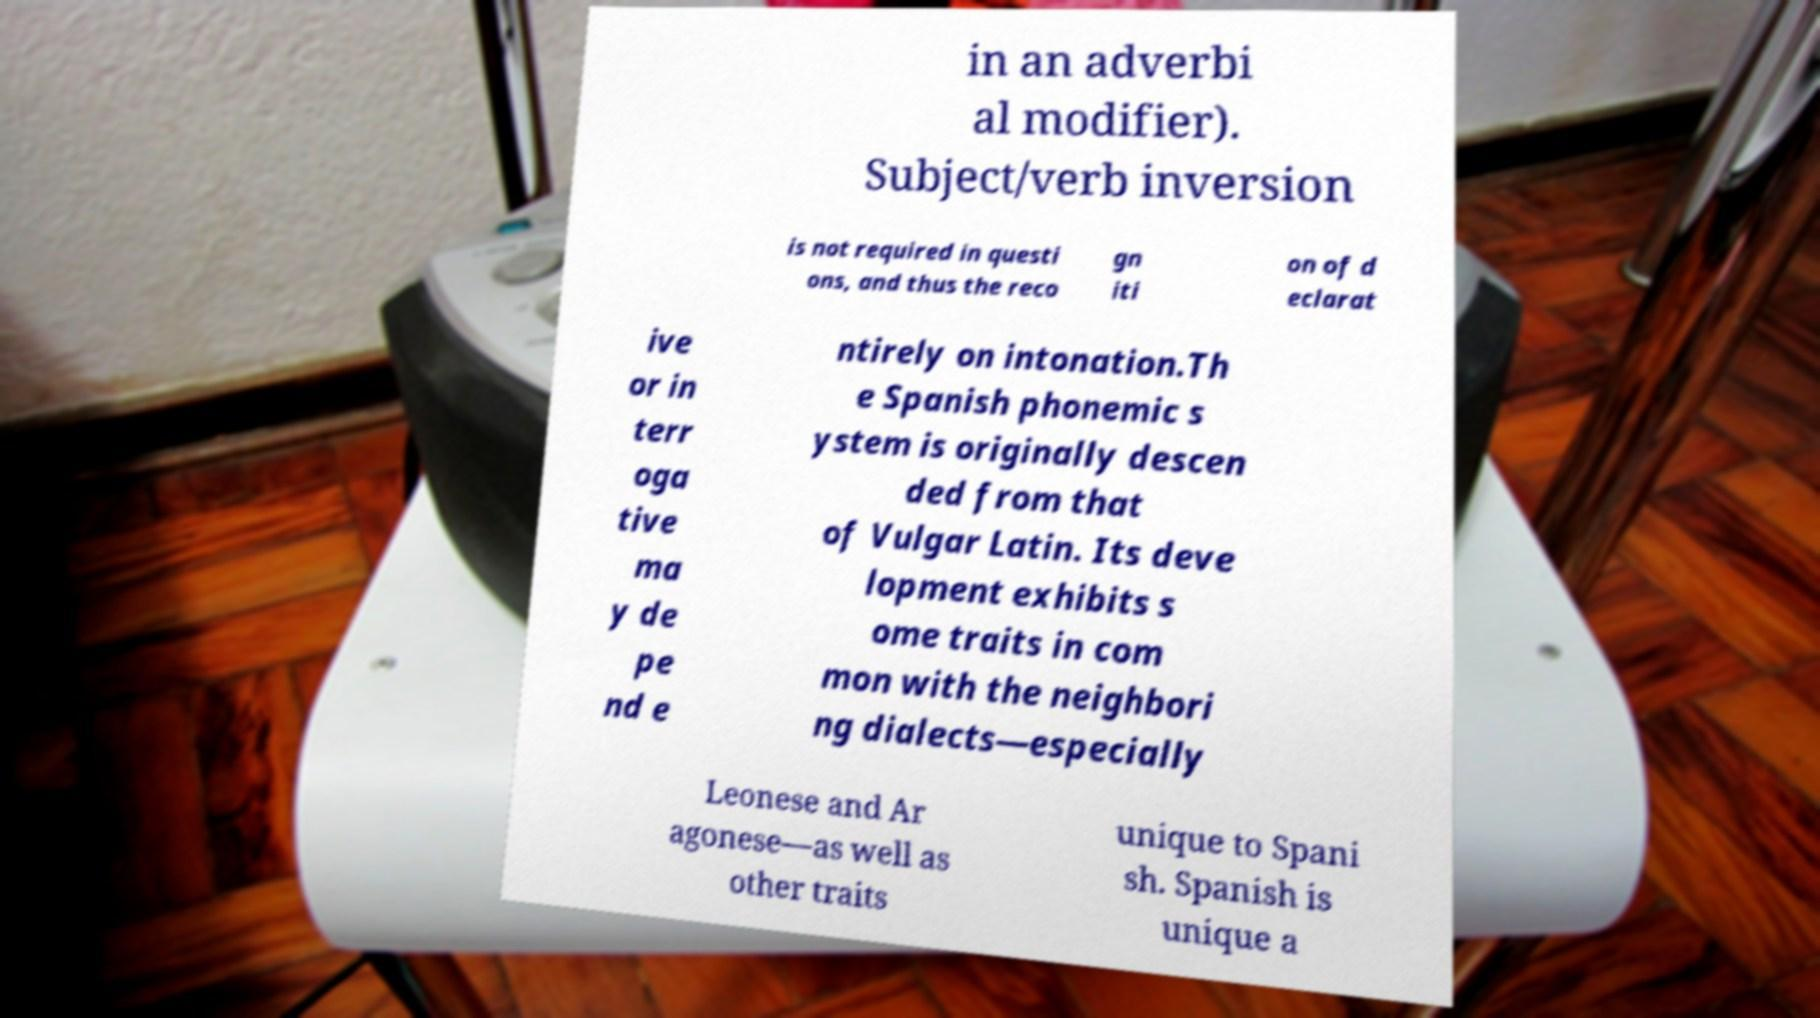What messages or text are displayed in this image? I need them in a readable, typed format. in an adverbi al modifier). Subject/verb inversion is not required in questi ons, and thus the reco gn iti on of d eclarat ive or in terr oga tive ma y de pe nd e ntirely on intonation.Th e Spanish phonemic s ystem is originally descen ded from that of Vulgar Latin. Its deve lopment exhibits s ome traits in com mon with the neighbori ng dialects—especially Leonese and Ar agonese—as well as other traits unique to Spani sh. Spanish is unique a 